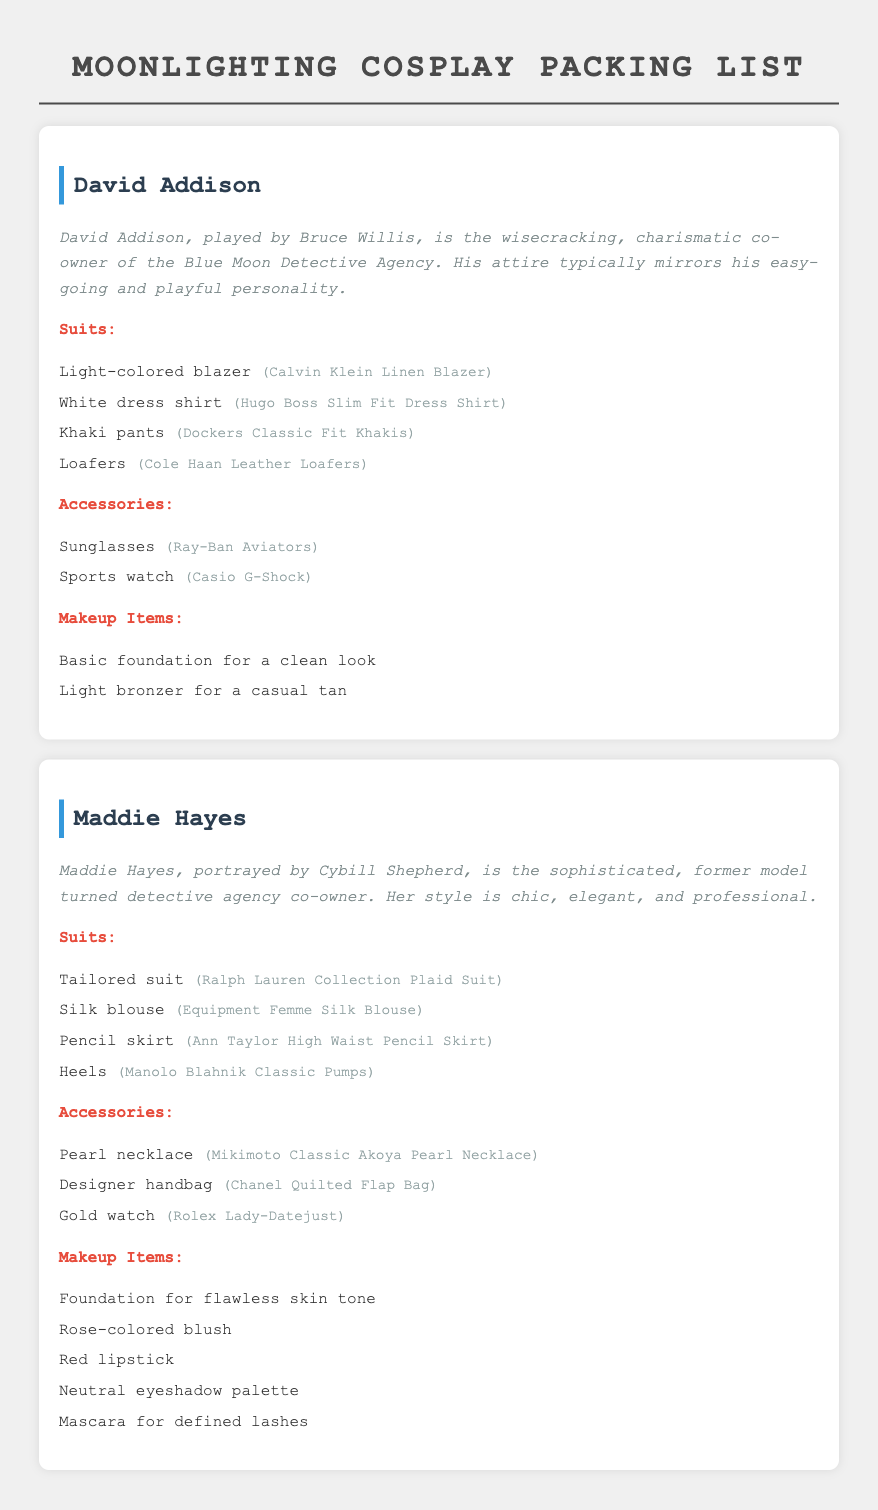what does David Addison typically wear? The document lists his attire which includes a light-colored blazer, white dress shirt, khaki pants, and loafers.
Answer: light-colored blazer, white dress shirt, khaki pants, loafers which makeup item is listed for Maddie Hayes? The document provides a list of makeup items specifically for Maddie Hayes, which includes foundation, blush, lipstick, eyeshadow, and mascara.
Answer: foundation, blush, lipstick, eyeshadow, mascara what accessory does David Addison wear? The document specifies accessories for David Addison, including sunglasses and sports watch.
Answer: sunglasses, sports watch how many suits are listed for Maddie Hayes? The document enumerates the suits listed for her, including a tailored suit, silk blouse, pencil skirt, and heels.
Answer: 4 what is the brand of David Addison's loafers? The document indicates that his loafers are from a specific brand.
Answer: Cole Haan Leather Loafers which character has a pearl necklace as an accessory? The document specifies that the pearl necklace is an accessory for one of the characters.
Answer: Maddie Hayes 